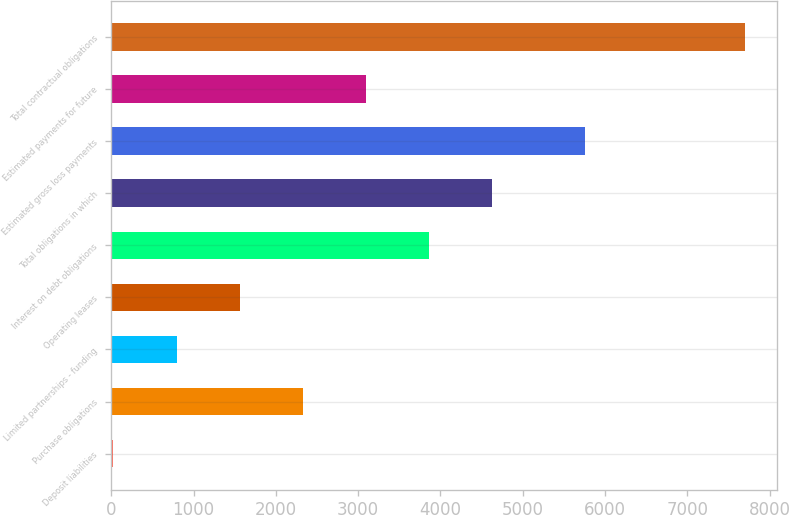<chart> <loc_0><loc_0><loc_500><loc_500><bar_chart><fcel>Deposit liabilities<fcel>Purchase obligations<fcel>Limited partnerships - funding<fcel>Operating leases<fcel>Interest on debt obligations<fcel>Total obligations in which<fcel>Estimated gross loss payments<fcel>Estimated payments for future<fcel>Total contractual obligations<nl><fcel>25<fcel>2327.5<fcel>792.5<fcel>1560<fcel>3862.5<fcel>4630<fcel>5760<fcel>3095<fcel>7700<nl></chart> 